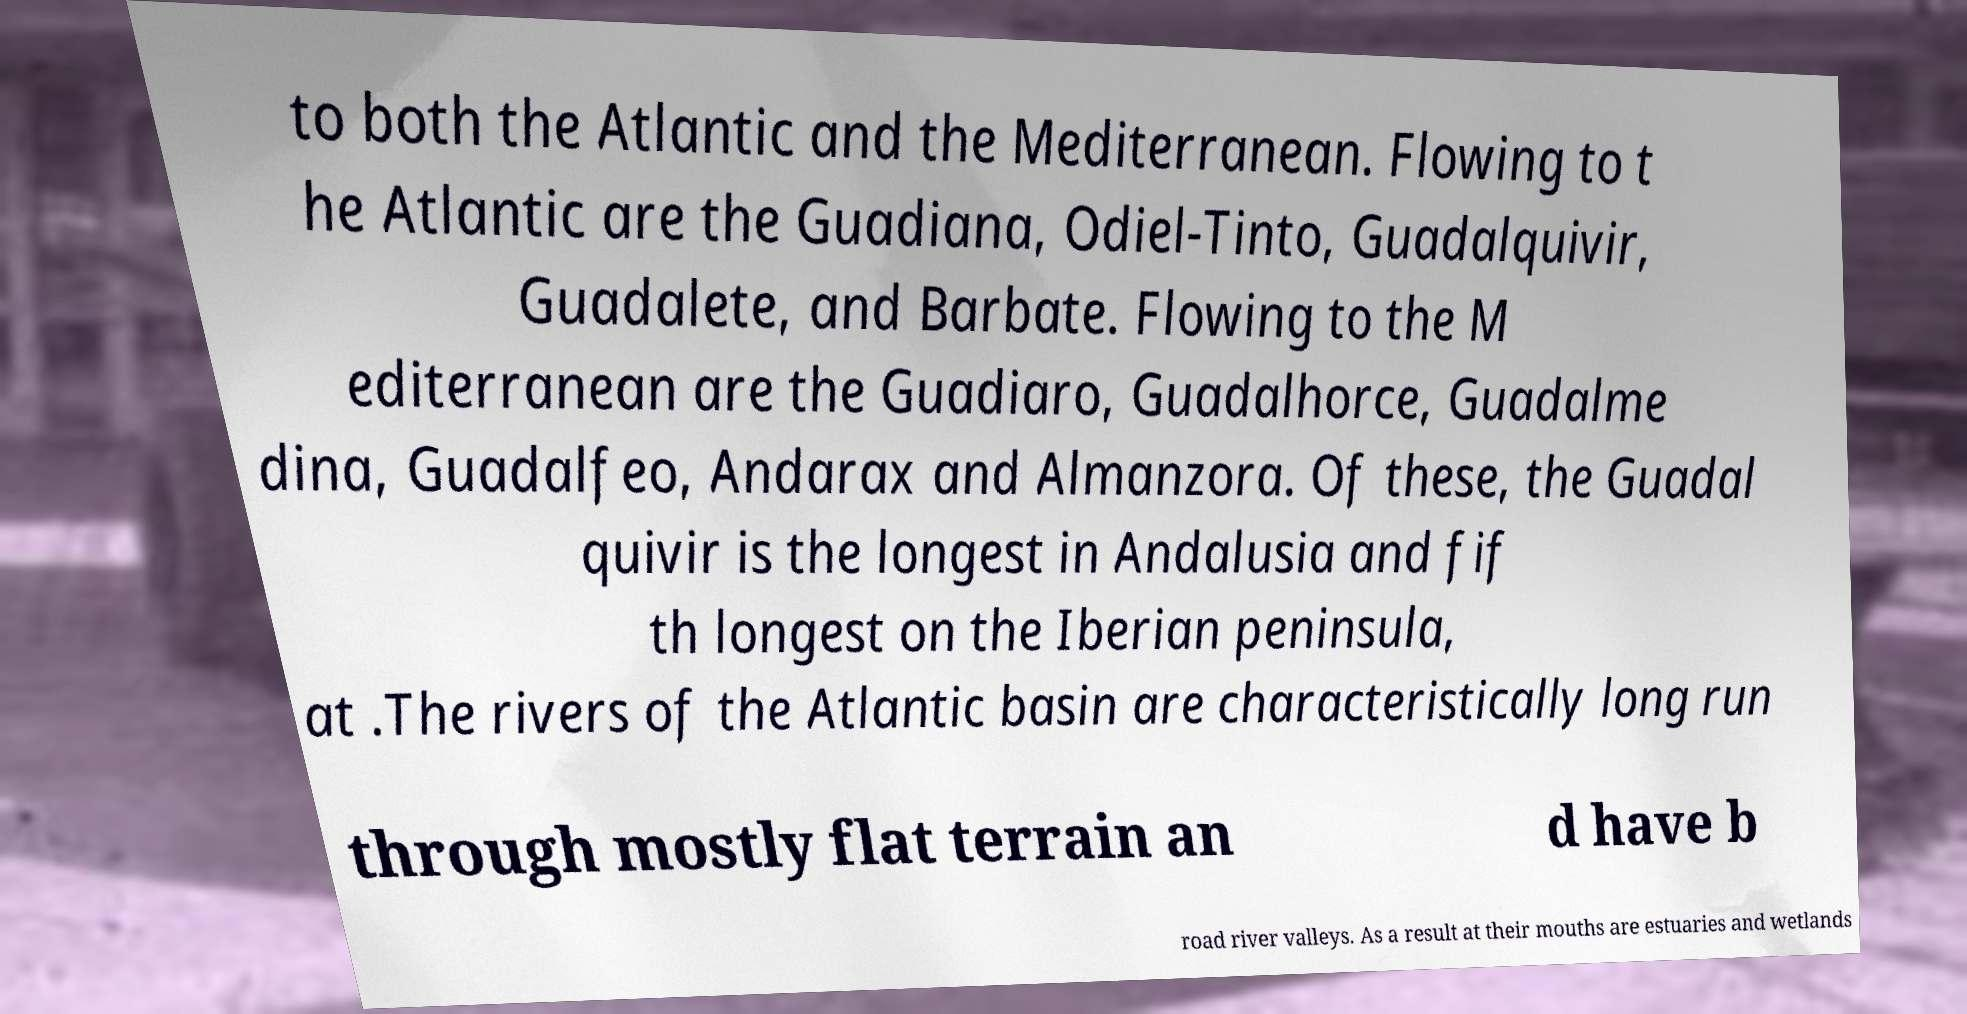Could you extract and type out the text from this image? to both the Atlantic and the Mediterranean. Flowing to t he Atlantic are the Guadiana, Odiel-Tinto, Guadalquivir, Guadalete, and Barbate. Flowing to the M editerranean are the Guadiaro, Guadalhorce, Guadalme dina, Guadalfeo, Andarax and Almanzora. Of these, the Guadal quivir is the longest in Andalusia and fif th longest on the Iberian peninsula, at .The rivers of the Atlantic basin are characteristically long run through mostly flat terrain an d have b road river valleys. As a result at their mouths are estuaries and wetlands 